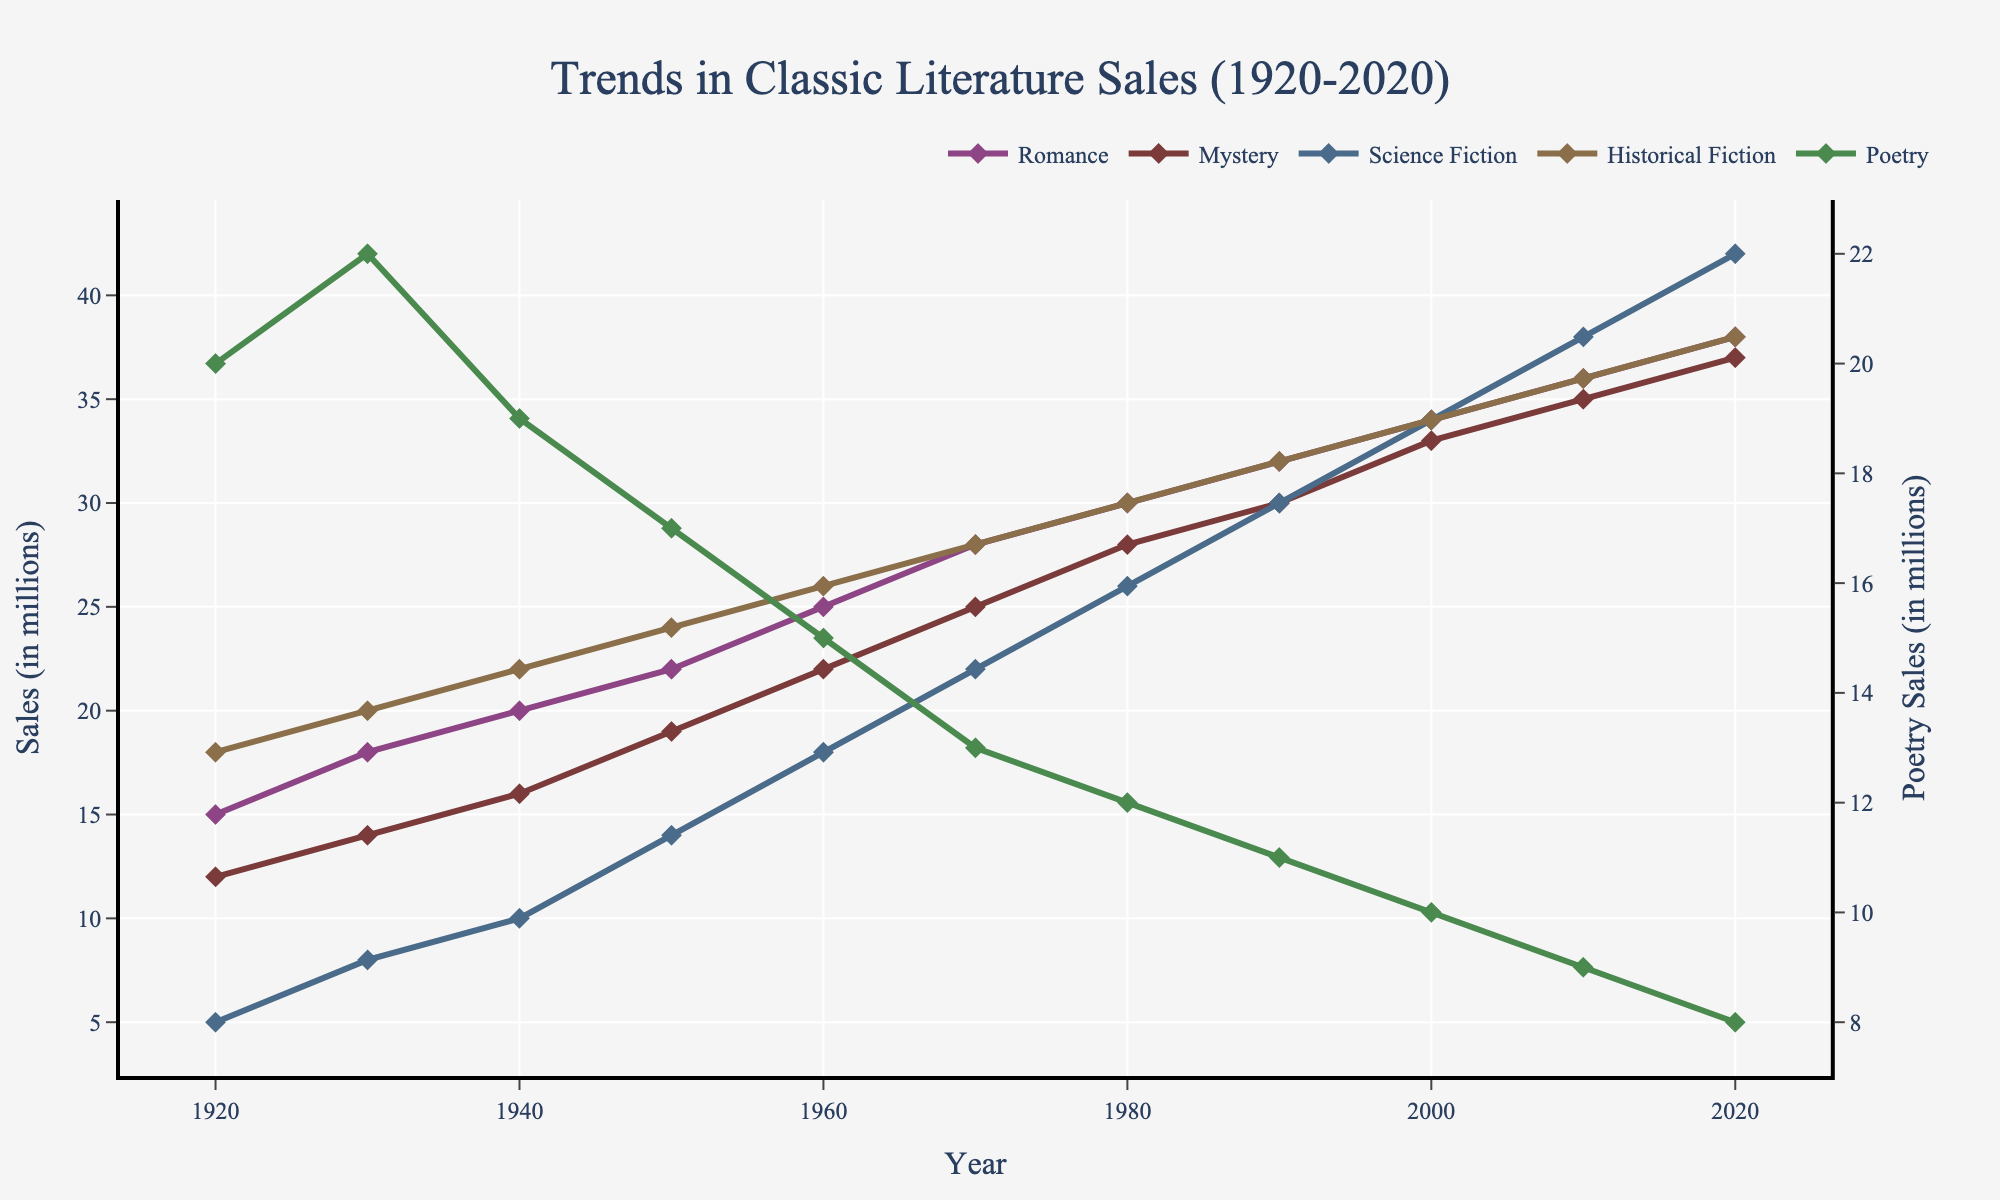What genre had the highest sales in 1920? By looking at the chart for 1920, we see that Poetry has the highest sales at 20 million.
Answer: Poetry Which genre experienced the greatest increase in sales from 1920 to 2020? Calculating the difference in sales from 1920 to 2020 for each genre, Romance increased by 23 million, Mystery by 25 million, Science Fiction by 37 million, Historical Fiction by 20 million, and Poetry decreased by 12 million. Science Fiction experienced the greatest increase.
Answer: Science Fiction In what year did Romance sales surpass Mystery sales? Comparing the lines for Romance and Mystery, Romance first surpasses Mystery in 1950, as the value for Romance is 22 million and for Mystery is 19 million.
Answer: 1950 What is the average sales of Historical Fiction from 1920 to 2020? Adding up Historical Fiction sales from 1920 to 2020 (18 + 20 + 22 + 24 + 26 + 28 + 30 + 32 + 34 + 36 + 38) and dividing by 11, the average is (278 / 11) = 25.27 million.
Answer: 25.27 million How do sales of Poetry in 2020 compare to sales of Mystery in 1950? In 2020, Poetry sales are 8 million, and in 1950, Mystery sales are 19 million, indicating that Mystery sales in 1950 were more than double the Poetry sales in 2020.
Answer: Mystery sales in 1950 were more Which genre showed a consistent increase each decade without any decline? Examining the lines for each genre, Romance, Mystery, Science Fiction, and Historical Fiction all showed consistent increases each decade, while Poetry declined. Hence Romance, Mystery, Science Fiction, and Historical Fiction qualify.
Answer: Romance, Mystery, Science Fiction, Historical Fiction What is the sum of Science Fiction sales and Poetry sales in 2000? Adding the sales of Science Fiction (34 million) and Poetry (10 million) in 2000, the total is (34 + 10) = 44 million.
Answer: 44 million What was the year when sales of all genres were exactly equal for the first time? The chart does not show a year where sales of all genres are equal.
Answer: Never Which genre had the slowest growth rate over the century? Comparing the differences between 1920 and 2020 for each genre, Historical Fiction increases by 20 million (38 - 18), which is the smallest increase among those that had growth. Hence, Historical Fiction had the slowest growth rate.
Answer: Historical Fiction What year did Science Fiction sales surpass Poetry sales for the first time? The chart shows Science Fiction surpassing Poetry sales between 1940 and 1950. In 1950, Science Fiction is at 14 million and Poetry is at 17 million. Hence, it occurs between 1950 and 1960 when Science Fiction exceeds 17 million.
Answer: Between 1950 and 1960 